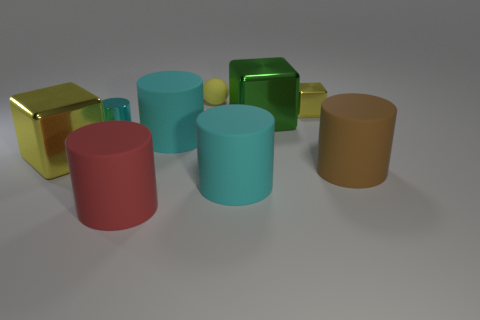Subtract all brown balls. Subtract all red cylinders. How many balls are left? 1 Subtract all cyan cylinders. How many gray balls are left? 0 Add 4 large cyans. How many browns exist? 0 Subtract all big brown cylinders. Subtract all big red rubber cylinders. How many objects are left? 7 Add 5 tiny cyan objects. How many tiny cyan objects are left? 6 Add 9 large green rubber things. How many large green rubber things exist? 9 Add 1 small yellow rubber balls. How many objects exist? 10 Subtract all cyan cylinders. How many cylinders are left? 2 Subtract all small shiny cubes. How many cubes are left? 2 Subtract 2 cyan cylinders. How many objects are left? 7 